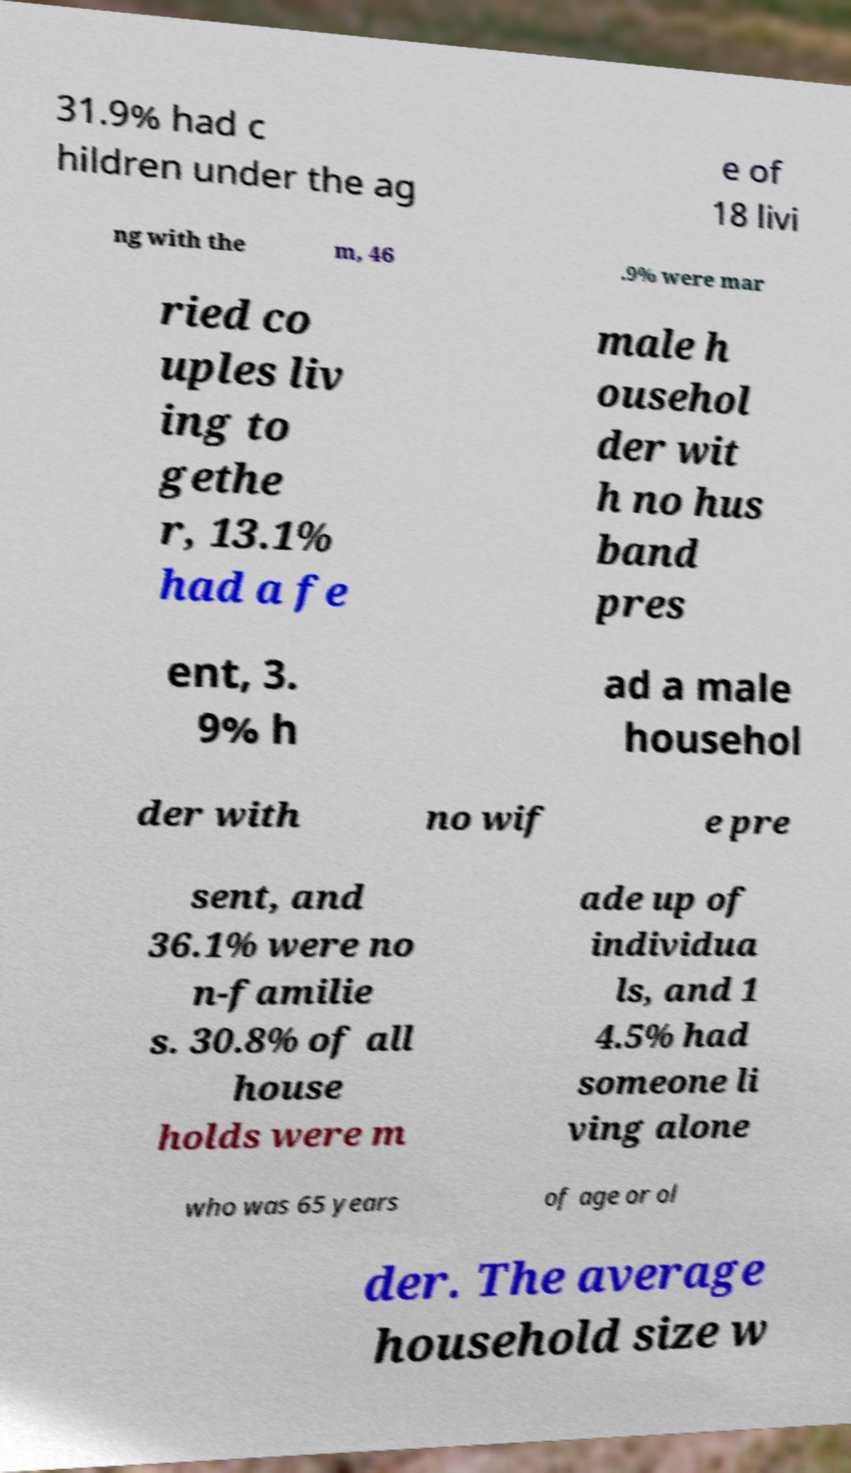I need the written content from this picture converted into text. Can you do that? 31.9% had c hildren under the ag e of 18 livi ng with the m, 46 .9% were mar ried co uples liv ing to gethe r, 13.1% had a fe male h ousehol der wit h no hus band pres ent, 3. 9% h ad a male househol der with no wif e pre sent, and 36.1% were no n-familie s. 30.8% of all house holds were m ade up of individua ls, and 1 4.5% had someone li ving alone who was 65 years of age or ol der. The average household size w 